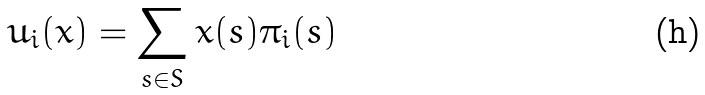Convert formula to latex. <formula><loc_0><loc_0><loc_500><loc_500>u _ { i } ( x ) = \sum _ { s \in S } x ( s ) \pi _ { i } ( s )</formula> 